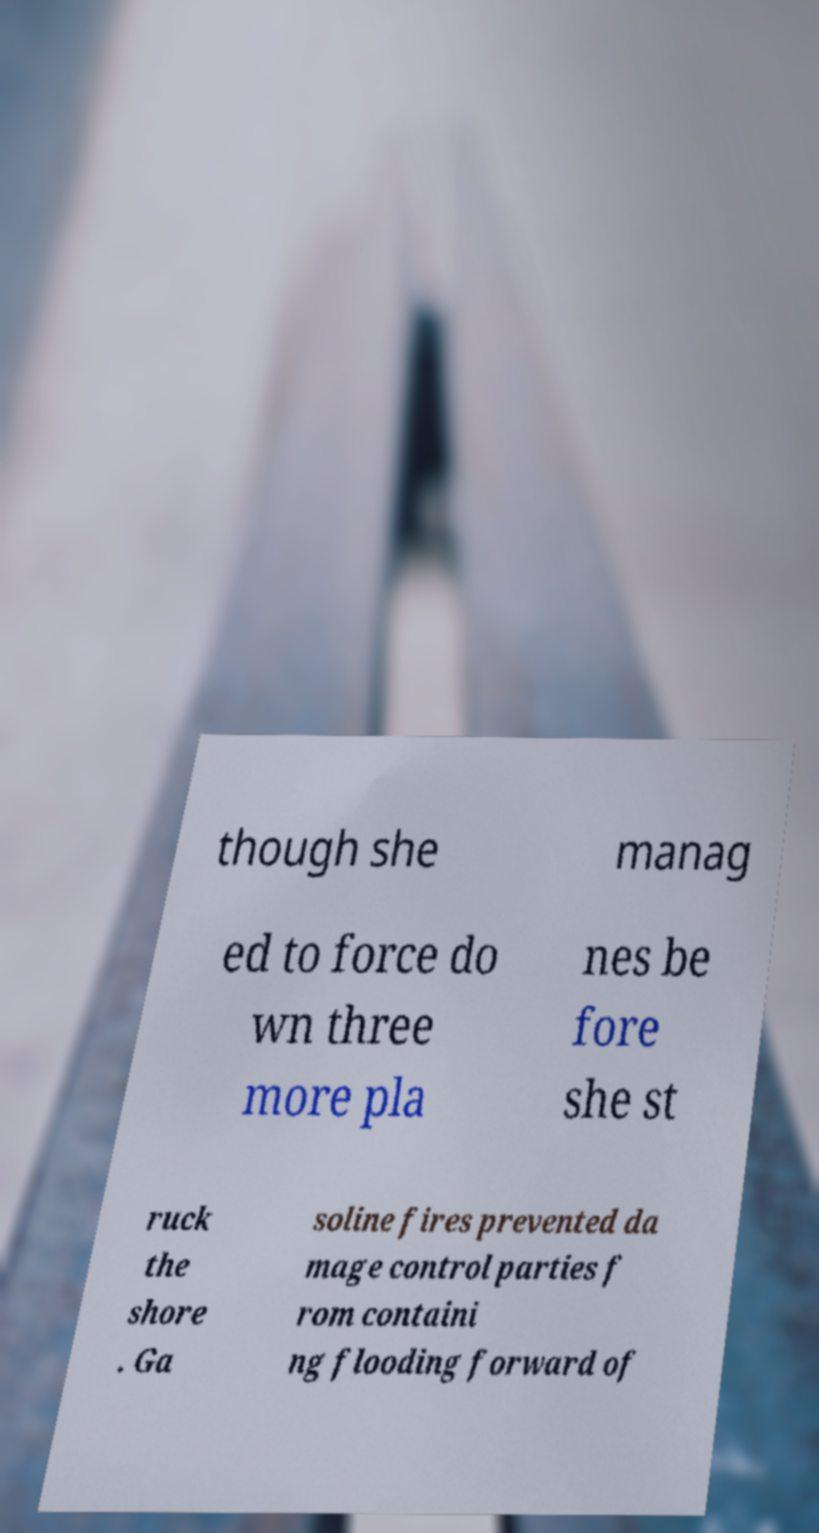I need the written content from this picture converted into text. Can you do that? though she manag ed to force do wn three more pla nes be fore she st ruck the shore . Ga soline fires prevented da mage control parties f rom containi ng flooding forward of 